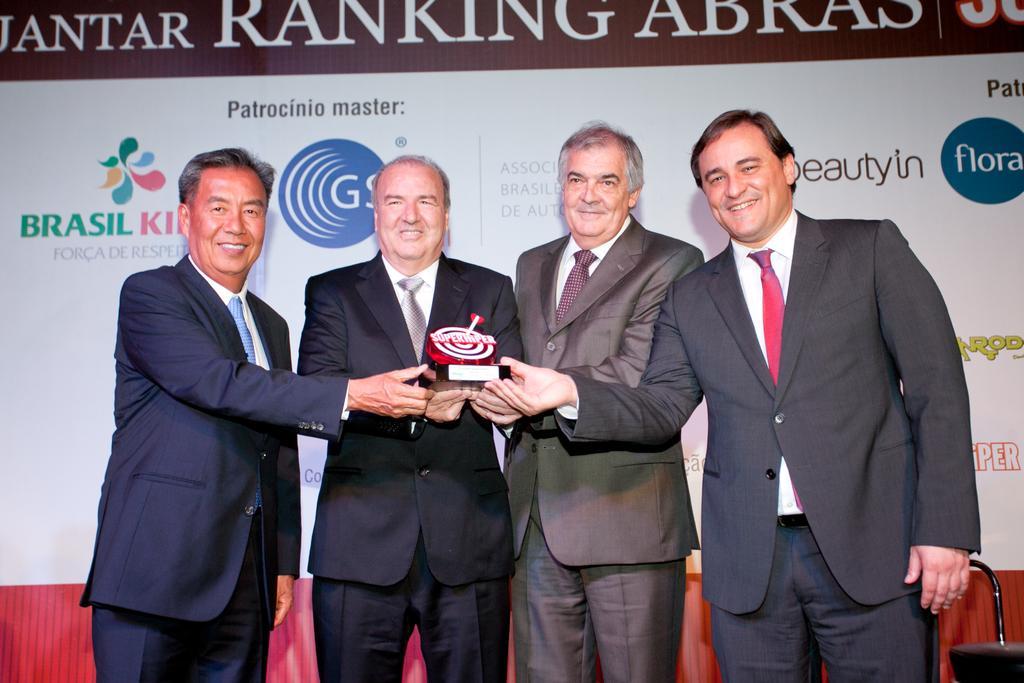In one or two sentences, can you explain what this image depicts? In this image we can see four persons holding an object, behind them there is a board with some text on it. 